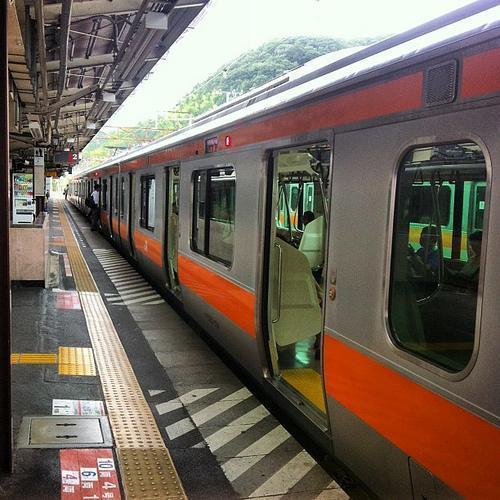How many trains are visible?
Give a very brief answer. 2. 